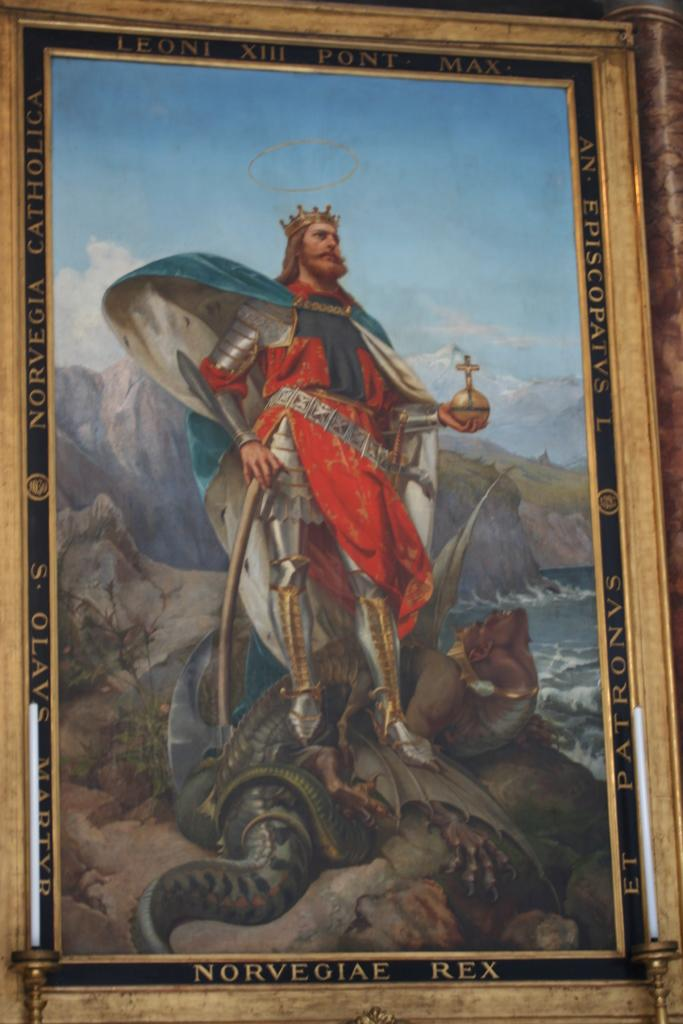<image>
Present a compact description of the photo's key features. A picture of a king with Norvegiae Rex on the frame. 